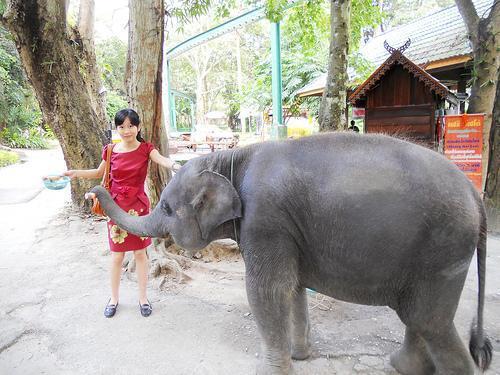How many people are there?
Give a very brief answer. 1. 